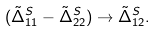<formula> <loc_0><loc_0><loc_500><loc_500>( \tilde { \Delta } _ { 1 1 } ^ { S } - \tilde { \Delta } _ { 2 2 } ^ { S } ) \rightarrow \tilde { \Delta } _ { 1 2 } ^ { S } .</formula> 